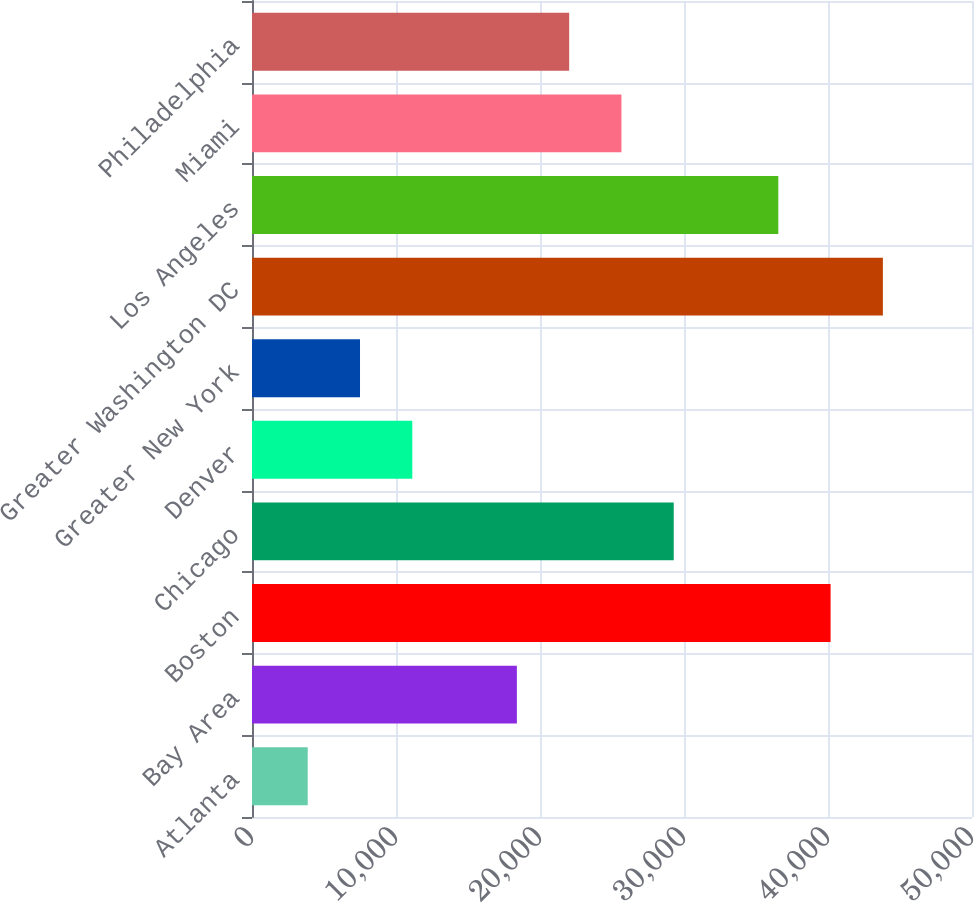<chart> <loc_0><loc_0><loc_500><loc_500><bar_chart><fcel>Atlanta<fcel>Bay Area<fcel>Boston<fcel>Chicago<fcel>Denver<fcel>Greater New York<fcel>Greater Washington DC<fcel>Los Angeles<fcel>Miami<fcel>Philadelphia<nl><fcel>3870<fcel>18394<fcel>40180<fcel>29287<fcel>11132<fcel>7501<fcel>43811<fcel>36549<fcel>25656<fcel>22025<nl></chart> 